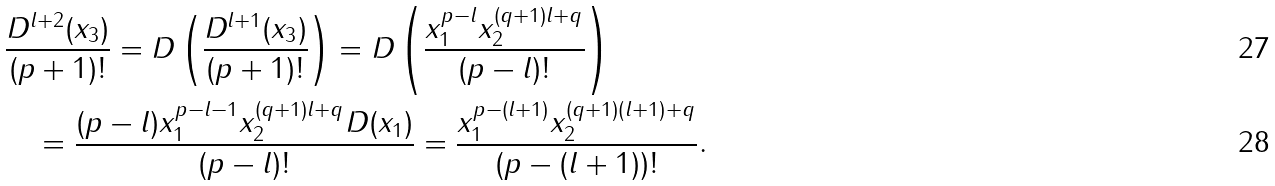<formula> <loc_0><loc_0><loc_500><loc_500>& \frac { D ^ { l + 2 } ( x _ { 3 } ) } { ( p + 1 ) ! } = D \left ( \frac { D ^ { l + 1 } ( x _ { 3 } ) } { ( p + 1 ) ! } \right ) = D \left ( \frac { x _ { 1 } ^ { p - l } x _ { 2 } ^ { ( q + 1 ) l + q } } { ( p - l ) ! } \right ) \\ & \quad = \frac { ( p - l ) x _ { 1 } ^ { p - l - 1 } x _ { 2 } ^ { ( q + 1 ) l + q } D ( x _ { 1 } ) } { ( p - l ) ! } = \frac { x _ { 1 } ^ { p - ( l + 1 ) } x _ { 2 } ^ { ( q + 1 ) ( l + 1 ) + q } } { ( p - ( l + 1 ) ) ! } .</formula> 